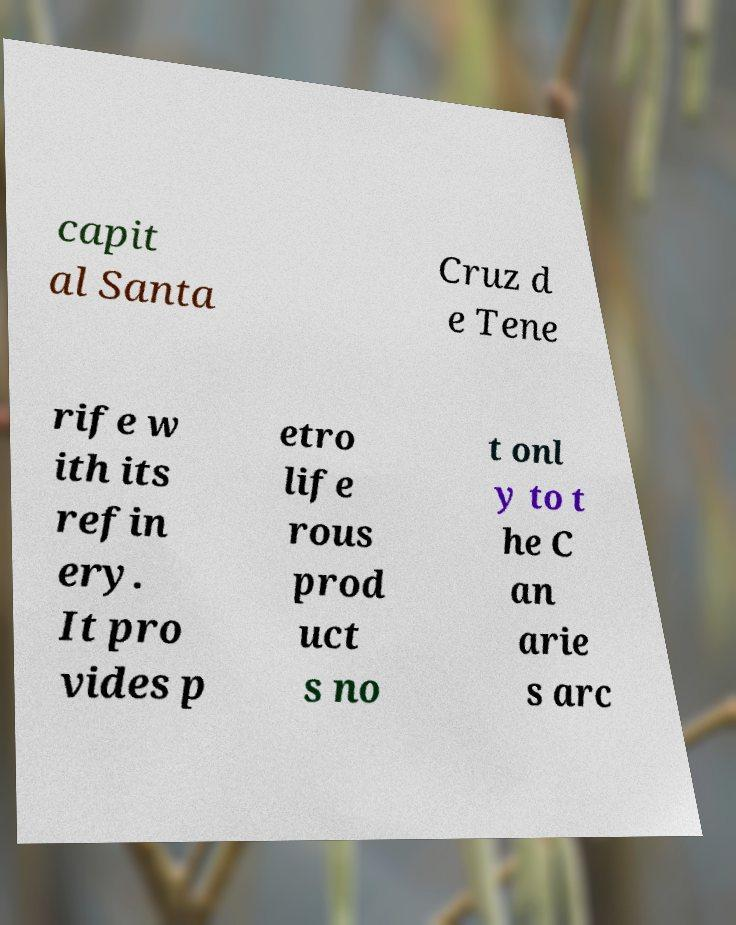For documentation purposes, I need the text within this image transcribed. Could you provide that? capit al Santa Cruz d e Tene rife w ith its refin ery. It pro vides p etro life rous prod uct s no t onl y to t he C an arie s arc 